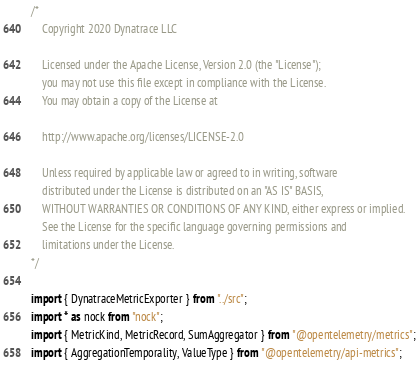Convert code to text. <code><loc_0><loc_0><loc_500><loc_500><_TypeScript_>/*
	Copyright 2020 Dynatrace LLC

	Licensed under the Apache License, Version 2.0 (the "License");
	you may not use this file except in compliance with the License.
	You may obtain a copy of the License at

	http://www.apache.org/licenses/LICENSE-2.0

	Unless required by applicable law or agreed to in writing, software
	distributed under the License is distributed on an "AS IS" BASIS,
	WITHOUT WARRANTIES OR CONDITIONS OF ANY KIND, either express or implied.
	See the License for the specific language governing permissions and
	limitations under the License.
*/

import { DynatraceMetricExporter } from "../src";
import * as nock from "nock";
import { MetricKind, MetricRecord, SumAggregator } from "@opentelemetry/metrics";
import { AggregationTemporality, ValueType } from "@opentelemetry/api-metrics";</code> 